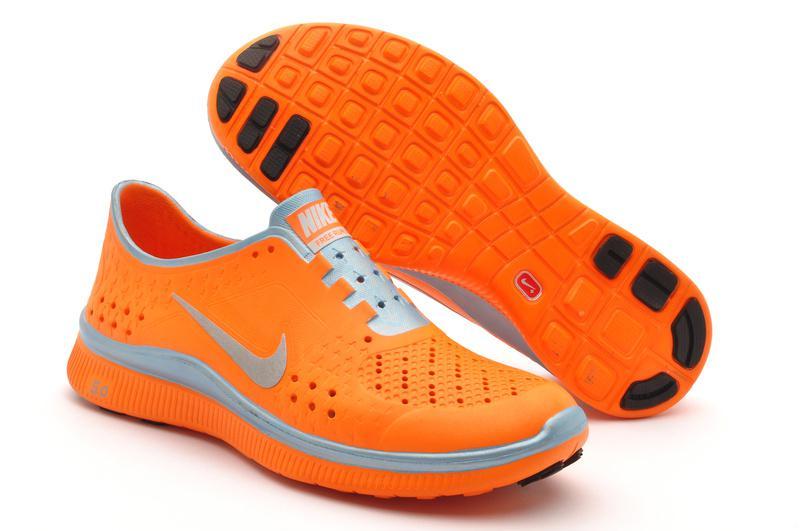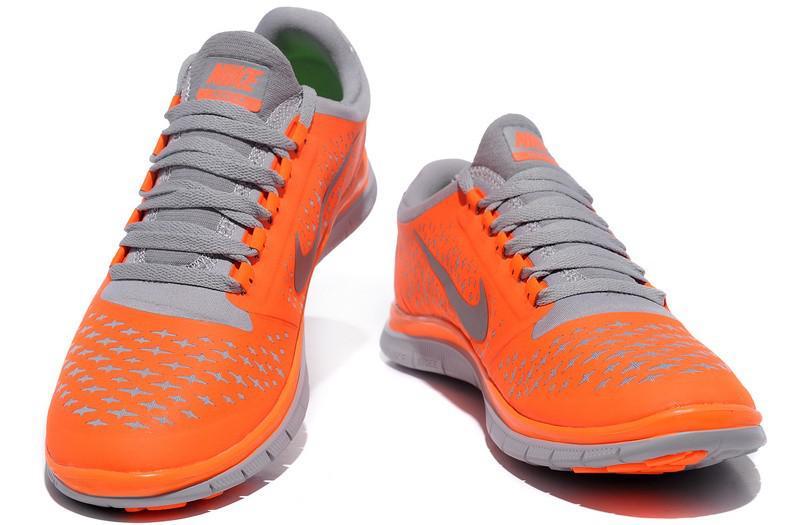The first image is the image on the left, the second image is the image on the right. Examine the images to the left and right. Is the description "One image features an orange shoe with a gray sole." accurate? Answer yes or no. Yes. The first image is the image on the left, the second image is the image on the right. Evaluate the accuracy of this statement regarding the images: "There is exactly one shoe in the image on the right.". Is it true? Answer yes or no. No. The first image is the image on the left, the second image is the image on the right. Considering the images on both sides, is "At least one pair of shoes with orange uppers is depicted." valid? Answer yes or no. Yes. 